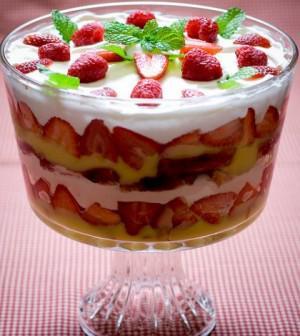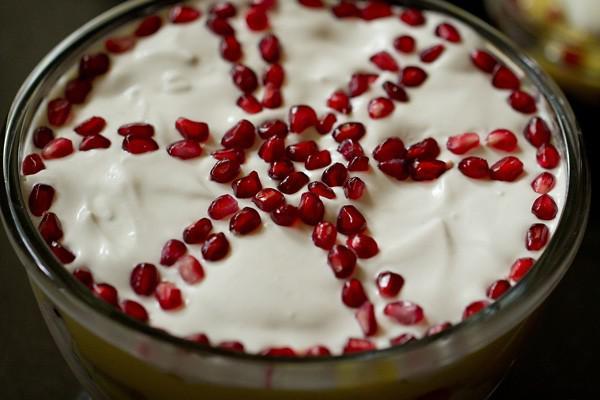The first image is the image on the left, the second image is the image on the right. Evaluate the accuracy of this statement regarding the images: "The desserts in the image on the left are being served in three glasses.". Is it true? Answer yes or no. No. The first image is the image on the left, the second image is the image on the right. For the images shown, is this caption "Two large fruit and cream desserts are ready to serve in clear bowls and are garnished with red fruit." true? Answer yes or no. Yes. 